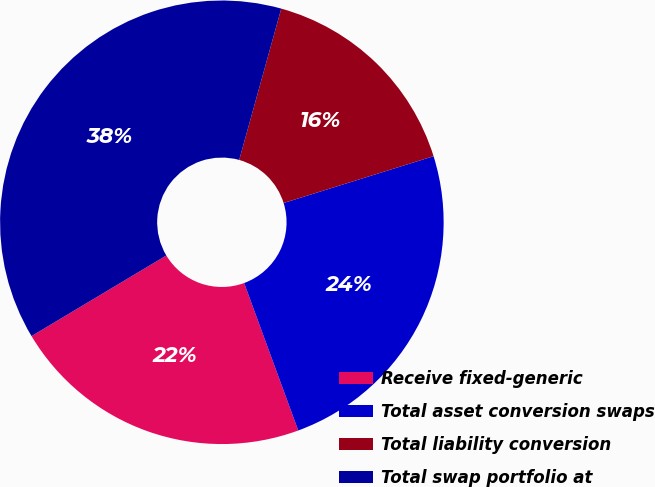Convert chart. <chart><loc_0><loc_0><loc_500><loc_500><pie_chart><fcel>Receive fixed-generic<fcel>Total asset conversion swaps<fcel>Total liability conversion<fcel>Total swap portfolio at<nl><fcel>22.02%<fcel>24.22%<fcel>15.87%<fcel>37.89%<nl></chart> 